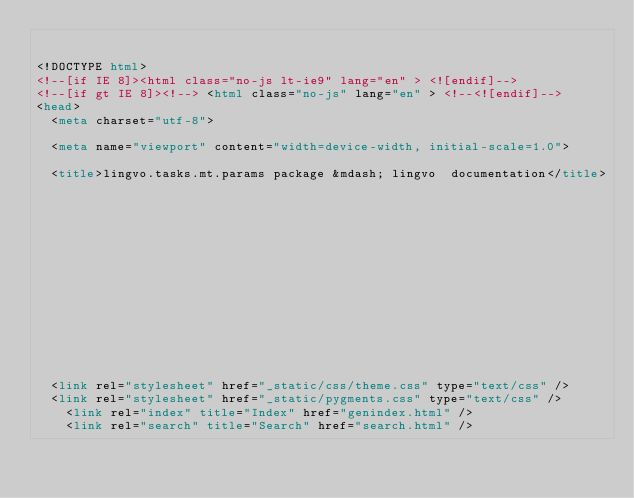Convert code to text. <code><loc_0><loc_0><loc_500><loc_500><_HTML_>

<!DOCTYPE html>
<!--[if IE 8]><html class="no-js lt-ie9" lang="en" > <![endif]-->
<!--[if gt IE 8]><!--> <html class="no-js" lang="en" > <!--<![endif]-->
<head>
  <meta charset="utf-8">
  
  <meta name="viewport" content="width=device-width, initial-scale=1.0">
  
  <title>lingvo.tasks.mt.params package &mdash; lingvo  documentation</title>
  

  
  
  
  

  

  
  
    

  

  <link rel="stylesheet" href="_static/css/theme.css" type="text/css" />
  <link rel="stylesheet" href="_static/pygments.css" type="text/css" />
    <link rel="index" title="Index" href="genindex.html" />
    <link rel="search" title="Search" href="search.html" /></code> 